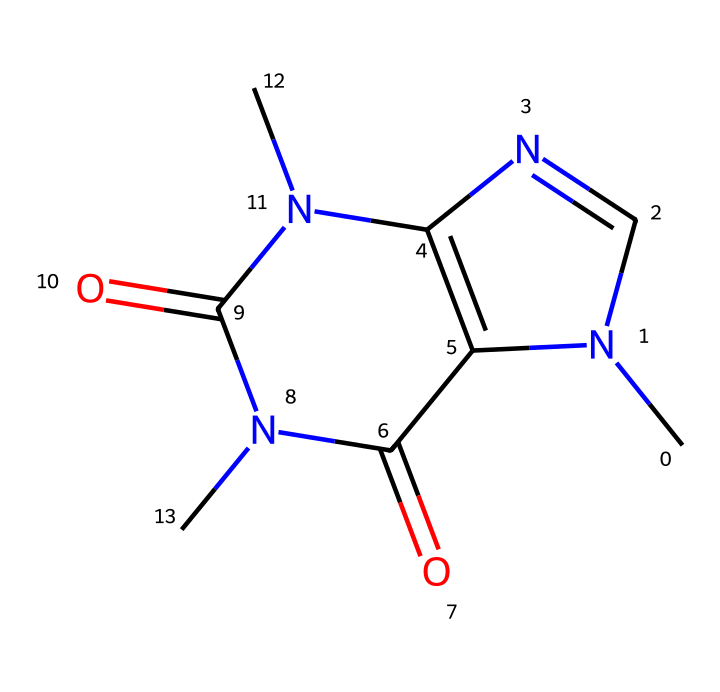how many rings are present in the caffeine structure? The SMILES notation indicates the presence of two interconnected cyclic structures. Observing the arrangement, we can identify two distinct ring formations through the notation.
Answer: 2 what is the total number of nitrogen atoms in this caffeine structure? By analyzing the SMILES structure, we see that three nitrogen atoms are present in the molecule, indicated by the 'N' symbols.
Answer: 3 what is the primary functional group present in caffeine? The SMILES representation shows the presence of amide groups, characterized by the connections of nitrogen atoms to carbonyl groups (C=O). This structure suggests the presence of two amide functional groups.
Answer: amide which property of caffeine is likely influenced by its nitrogen content? The nitrogen atoms in caffeine contribute to its basicity due to their electron-rich nature. This characteristic impacts how caffeine interacts with biological systems, influencing its pharmacological effects.
Answer: basicity which element is predominantly found in caffeine's structure? The analysis shows that carbon atoms are the most commonly occurring elements in the caffeine structure. There are a total of 8 carbon atoms present.
Answer: carbon how does the structure of caffeine contribute to its stimulant properties? The structure of caffeine includes nitrogen atoms and the arrangement of the rings, which allows it to interact with adenosine receptors in the brain, inhibiting their action and resulting in a stimulant effect. Thus, the molecular configuration is crucial for its stimulating properties.
Answer: stimulant properties 